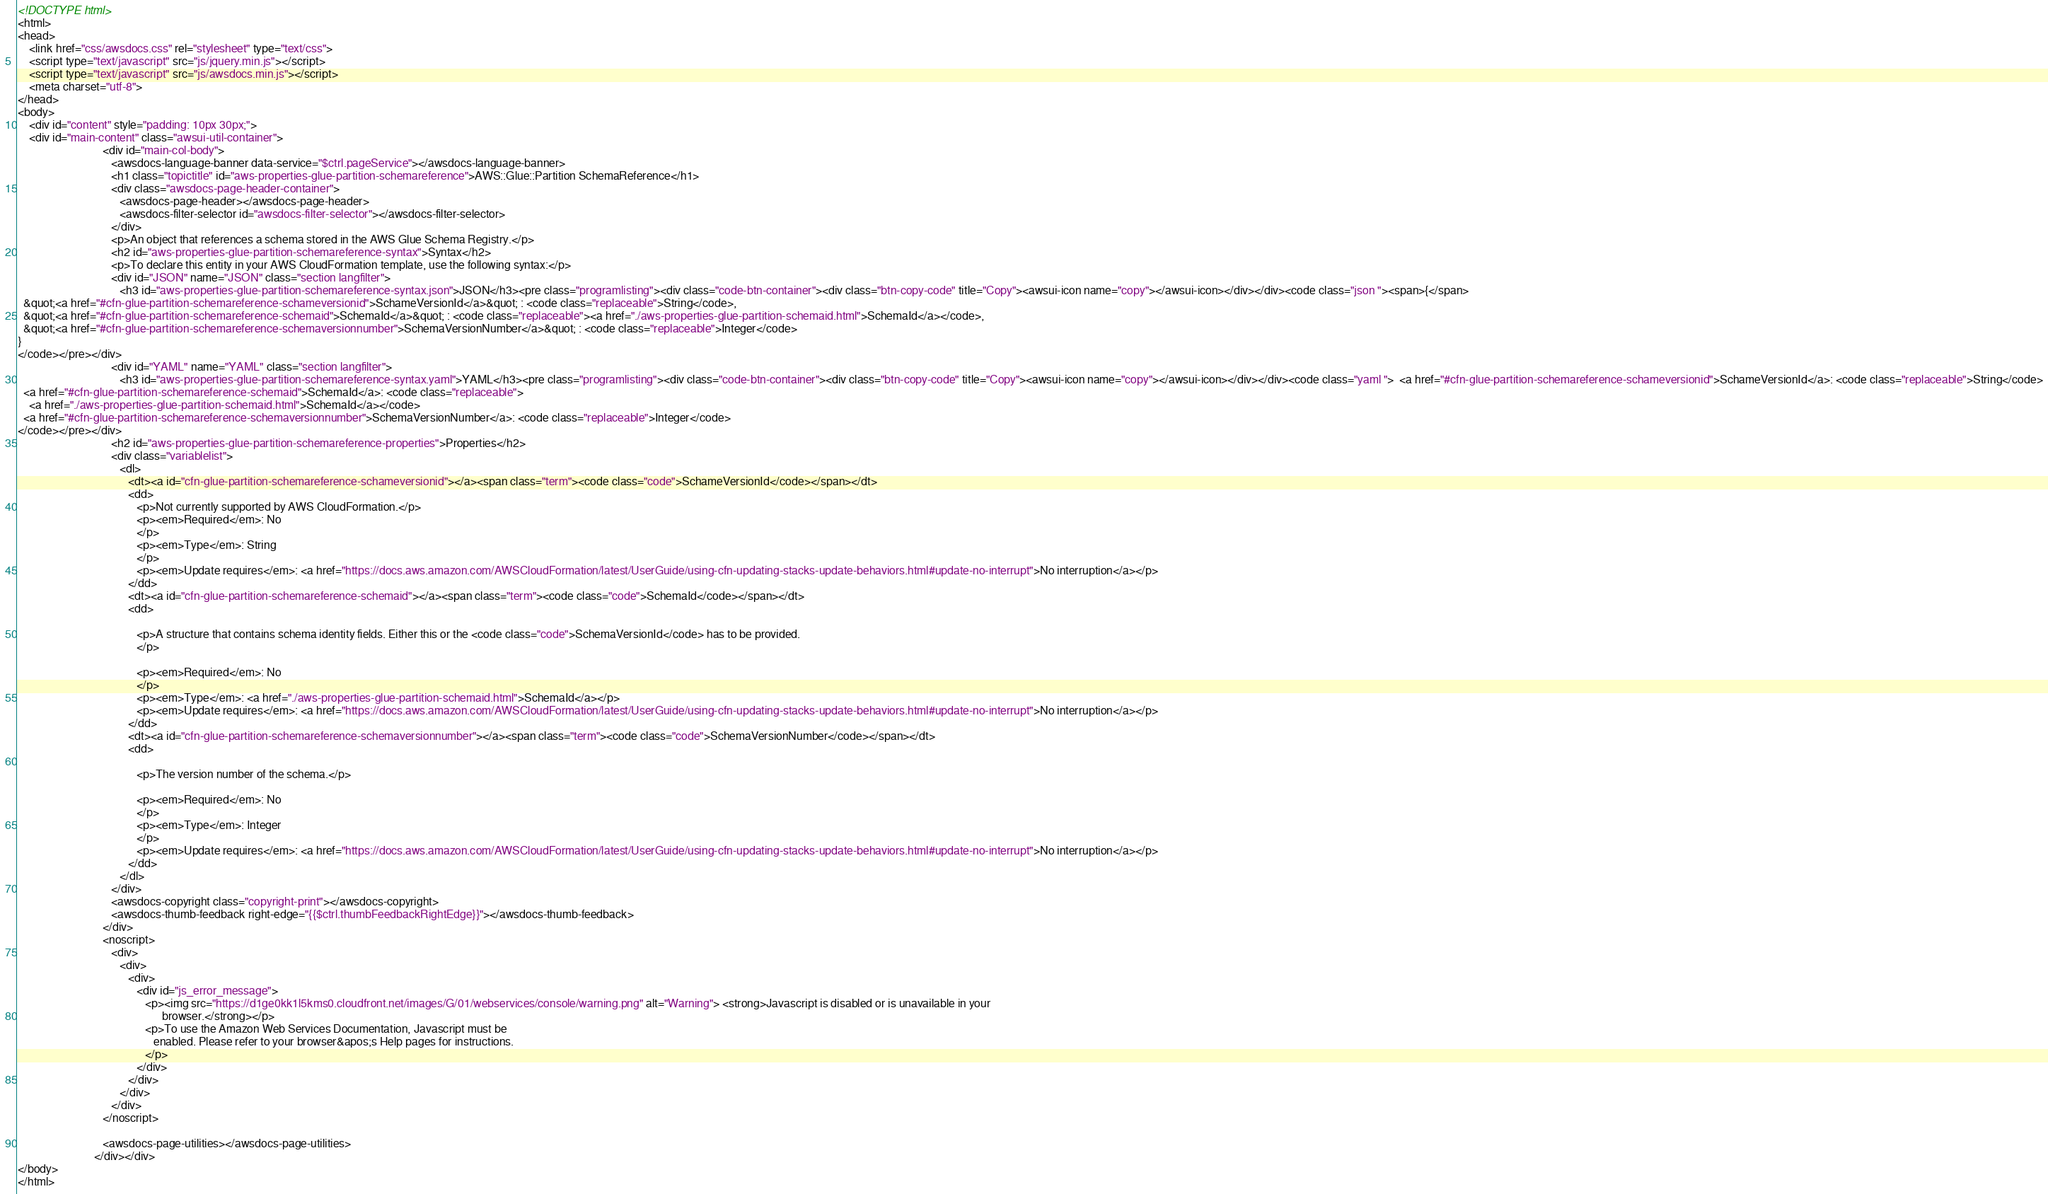<code> <loc_0><loc_0><loc_500><loc_500><_HTML_><!DOCTYPE html>
<html>
<head>
    <link href="css/awsdocs.css" rel="stylesheet" type="text/css">
    <script type="text/javascript" src="js/jquery.min.js"></script>
    <script type="text/javascript" src="js/awsdocs.min.js"></script>
    <meta charset="utf-8">
</head>
<body>
    <div id="content" style="padding: 10px 30px;">
    <div id="main-content" class="awsui-util-container">
                              <div id="main-col-body">
                                 <awsdocs-language-banner data-service="$ctrl.pageService"></awsdocs-language-banner>
                                 <h1 class="topictitle" id="aws-properties-glue-partition-schemareference">AWS::Glue::Partition SchemaReference</h1>
                                 <div class="awsdocs-page-header-container">
                                    <awsdocs-page-header></awsdocs-page-header>
                                    <awsdocs-filter-selector id="awsdocs-filter-selector"></awsdocs-filter-selector>
                                 </div>
                                 <p>An object that references a schema stored in the AWS Glue Schema Registry.</p>
                                 <h2 id="aws-properties-glue-partition-schemareference-syntax">Syntax</h2>
                                 <p>To declare this entity in your AWS CloudFormation template, use the following syntax:</p>
                                 <div id="JSON" name="JSON" class="section langfilter">
                                    <h3 id="aws-properties-glue-partition-schemareference-syntax.json">JSON</h3><pre class="programlisting"><div class="code-btn-container"><div class="btn-copy-code" title="Copy"><awsui-icon name="copy"></awsui-icon></div></div><code class="json "><span>{</span>
  &quot;<a href="#cfn-glue-partition-schemareference-schameversionid">SchameVersionId</a>&quot; : <code class="replaceable">String</code>,
  &quot;<a href="#cfn-glue-partition-schemareference-schemaid">SchemaId</a>&quot; : <code class="replaceable"><a href="./aws-properties-glue-partition-schemaid.html">SchemaId</a></code>,
  &quot;<a href="#cfn-glue-partition-schemareference-schemaversionnumber">SchemaVersionNumber</a>&quot; : <code class="replaceable">Integer</code>
}
</code></pre></div>
                                 <div id="YAML" name="YAML" class="section langfilter">
                                    <h3 id="aws-properties-glue-partition-schemareference-syntax.yaml">YAML</h3><pre class="programlisting"><div class="code-btn-container"><div class="btn-copy-code" title="Copy"><awsui-icon name="copy"></awsui-icon></div></div><code class="yaml ">  <a href="#cfn-glue-partition-schemareference-schameversionid">SchameVersionId</a>: <code class="replaceable">String</code>
  <a href="#cfn-glue-partition-schemareference-schemaid">SchemaId</a>: <code class="replaceable">
    <a href="./aws-properties-glue-partition-schemaid.html">SchemaId</a></code>
  <a href="#cfn-glue-partition-schemareference-schemaversionnumber">SchemaVersionNumber</a>: <code class="replaceable">Integer</code>
</code></pre></div>
                                 <h2 id="aws-properties-glue-partition-schemareference-properties">Properties</h2>
                                 <div class="variablelist">
                                    <dl>
                                       <dt><a id="cfn-glue-partition-schemareference-schameversionid"></a><span class="term"><code class="code">SchameVersionId</code></span></dt>
                                       <dd>
                                          <p>Not currently supported by AWS CloudFormation.</p>
                                          <p><em>Required</em>: No
                                          </p>
                                          <p><em>Type</em>: String
                                          </p>
                                          <p><em>Update requires</em>: <a href="https://docs.aws.amazon.com/AWSCloudFormation/latest/UserGuide/using-cfn-updating-stacks-update-behaviors.html#update-no-interrupt">No interruption</a></p>
                                       </dd>
                                       <dt><a id="cfn-glue-partition-schemareference-schemaid"></a><span class="term"><code class="code">SchemaId</code></span></dt>
                                       <dd>
                                          
                                          <p>A structure that contains schema identity fields. Either this or the <code class="code">SchemaVersionId</code> has to be provided.
                                          </p>
                                          
                                          <p><em>Required</em>: No
                                          </p>
                                          <p><em>Type</em>: <a href="./aws-properties-glue-partition-schemaid.html">SchemaId</a></p>
                                          <p><em>Update requires</em>: <a href="https://docs.aws.amazon.com/AWSCloudFormation/latest/UserGuide/using-cfn-updating-stacks-update-behaviors.html#update-no-interrupt">No interruption</a></p>
                                       </dd>
                                       <dt><a id="cfn-glue-partition-schemareference-schemaversionnumber"></a><span class="term"><code class="code">SchemaVersionNumber</code></span></dt>
                                       <dd>
                                          
                                          <p>The version number of the schema.</p>
                                          
                                          <p><em>Required</em>: No
                                          </p>
                                          <p><em>Type</em>: Integer
                                          </p>
                                          <p><em>Update requires</em>: <a href="https://docs.aws.amazon.com/AWSCloudFormation/latest/UserGuide/using-cfn-updating-stacks-update-behaviors.html#update-no-interrupt">No interruption</a></p>
                                       </dd>
                                    </dl>
                                 </div>
                                 <awsdocs-copyright class="copyright-print"></awsdocs-copyright>
                                 <awsdocs-thumb-feedback right-edge="{{$ctrl.thumbFeedbackRightEdge}}"></awsdocs-thumb-feedback>
                              </div>
                              <noscript>
                                 <div>
                                    <div>
                                       <div>
                                          <div id="js_error_message">
                                             <p><img src="https://d1ge0kk1l5kms0.cloudfront.net/images/G/01/webservices/console/warning.png" alt="Warning"> <strong>Javascript is disabled or is unavailable in your
                                                   browser.</strong></p>
                                             <p>To use the Amazon Web Services Documentation, Javascript must be
                                                enabled. Please refer to your browser&apos;s Help pages for instructions.
                                             </p>
                                          </div>
                                       </div>
                                    </div>
                                 </div>
                              </noscript>
                              
                              <awsdocs-page-utilities></awsdocs-page-utilities>
                           </div></div>
</body>
</html></code> 